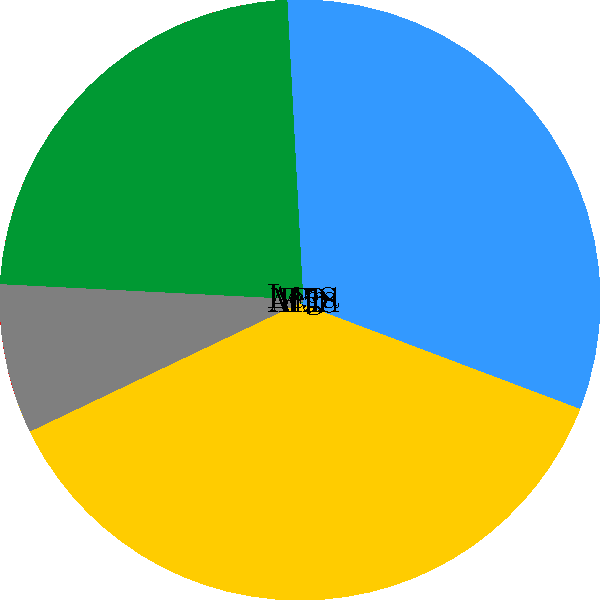Based on the pie chart representing the distribution of parliamentary seats in Italy, which party has the second-largest share, and what percentage of seats does it hold? To answer this question, we need to analyze the pie chart carefully:

1. First, we identify all the parties represented in the chart:
   - PD (Partito Democratico)
   - M5S (Movimento 5 Stelle)
   - FI (Forza Italia)
   - Lega
   - Altri (Others)

2. We observe that the pie chart is divided into sections, with each section representing a party's share of seats.

3. The largest section belongs to PD, which is not the focus of our question.

4. The second-largest section belongs to M5S (Movimento 5 Stelle).

5. To determine the percentage of seats held by M5S, we need to look at the data provided in the chart.

6. The chart shows that M5S holds 25% of the seats.

Therefore, the party with the second-largest share is M5S, holding 25% of the parliamentary seats.
Answer: M5S, 25% 